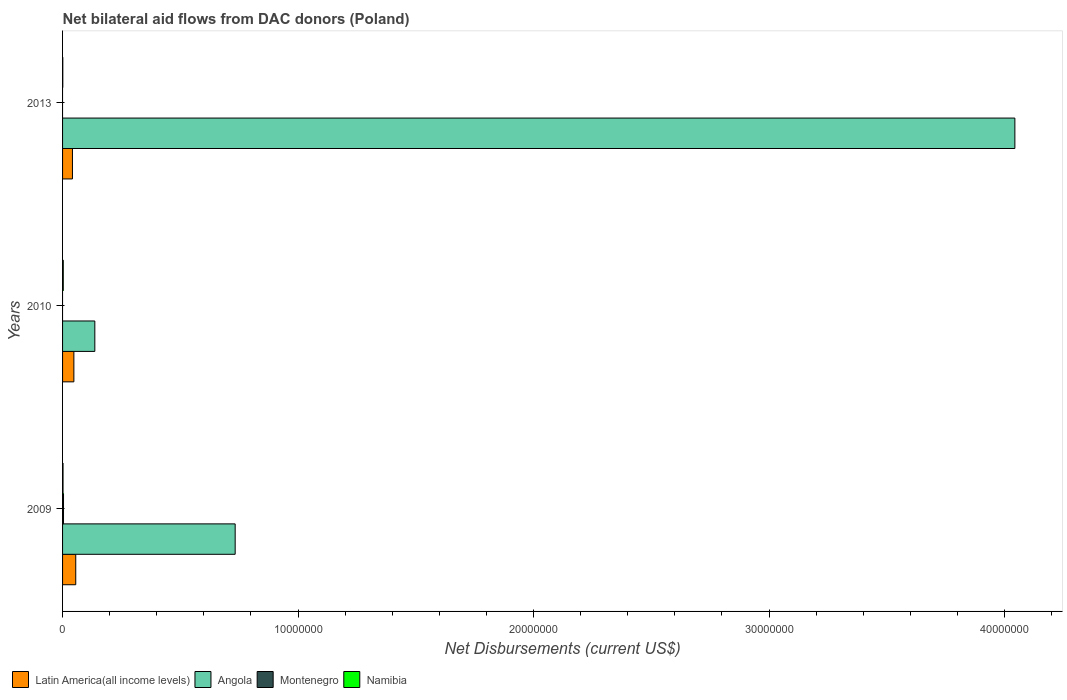How many different coloured bars are there?
Ensure brevity in your answer.  4. Are the number of bars per tick equal to the number of legend labels?
Your response must be concise. No. Are the number of bars on each tick of the Y-axis equal?
Offer a very short reply. No. How many bars are there on the 1st tick from the top?
Provide a succinct answer. 3. How many bars are there on the 2nd tick from the bottom?
Your answer should be very brief. 3. What is the label of the 3rd group of bars from the top?
Your answer should be compact. 2009. What is the net bilateral aid flows in Namibia in 2009?
Your response must be concise. 2.00e+04. Across all years, what is the maximum net bilateral aid flows in Latin America(all income levels)?
Keep it short and to the point. 5.60e+05. What is the total net bilateral aid flows in Namibia in the graph?
Offer a terse response. 6.00e+04. What is the difference between the net bilateral aid flows in Angola in 2009 and that in 2013?
Your answer should be compact. -3.31e+07. What is the average net bilateral aid flows in Latin America(all income levels) per year?
Your answer should be very brief. 4.87e+05. In the year 2010, what is the difference between the net bilateral aid flows in Angola and net bilateral aid flows in Latin America(all income levels)?
Offer a very short reply. 8.90e+05. What is the ratio of the net bilateral aid flows in Namibia in 2009 to that in 2010?
Offer a terse response. 0.67. Is the net bilateral aid flows in Namibia in 2009 less than that in 2010?
Provide a short and direct response. Yes. What is the difference between the highest and the lowest net bilateral aid flows in Namibia?
Your answer should be compact. 2.00e+04. In how many years, is the net bilateral aid flows in Namibia greater than the average net bilateral aid flows in Namibia taken over all years?
Keep it short and to the point. 1. Is it the case that in every year, the sum of the net bilateral aid flows in Angola and net bilateral aid flows in Namibia is greater than the net bilateral aid flows in Latin America(all income levels)?
Keep it short and to the point. Yes. How many bars are there?
Give a very brief answer. 10. How many years are there in the graph?
Offer a terse response. 3. Are the values on the major ticks of X-axis written in scientific E-notation?
Your response must be concise. No. How are the legend labels stacked?
Offer a very short reply. Horizontal. What is the title of the graph?
Make the answer very short. Net bilateral aid flows from DAC donors (Poland). Does "Algeria" appear as one of the legend labels in the graph?
Give a very brief answer. No. What is the label or title of the X-axis?
Offer a very short reply. Net Disbursements (current US$). What is the label or title of the Y-axis?
Offer a terse response. Years. What is the Net Disbursements (current US$) of Latin America(all income levels) in 2009?
Make the answer very short. 5.60e+05. What is the Net Disbursements (current US$) in Angola in 2009?
Offer a very short reply. 7.33e+06. What is the Net Disbursements (current US$) in Angola in 2010?
Offer a very short reply. 1.37e+06. What is the Net Disbursements (current US$) in Namibia in 2010?
Your response must be concise. 3.00e+04. What is the Net Disbursements (current US$) in Latin America(all income levels) in 2013?
Give a very brief answer. 4.20e+05. What is the Net Disbursements (current US$) in Angola in 2013?
Ensure brevity in your answer.  4.04e+07. What is the Net Disbursements (current US$) in Namibia in 2013?
Your answer should be very brief. 10000. Across all years, what is the maximum Net Disbursements (current US$) of Latin America(all income levels)?
Your answer should be compact. 5.60e+05. Across all years, what is the maximum Net Disbursements (current US$) of Angola?
Offer a terse response. 4.04e+07. Across all years, what is the maximum Net Disbursements (current US$) of Montenegro?
Make the answer very short. 4.00e+04. Across all years, what is the minimum Net Disbursements (current US$) in Latin America(all income levels)?
Provide a succinct answer. 4.20e+05. Across all years, what is the minimum Net Disbursements (current US$) in Angola?
Your response must be concise. 1.37e+06. Across all years, what is the minimum Net Disbursements (current US$) in Montenegro?
Your response must be concise. 0. Across all years, what is the minimum Net Disbursements (current US$) in Namibia?
Ensure brevity in your answer.  10000. What is the total Net Disbursements (current US$) in Latin America(all income levels) in the graph?
Keep it short and to the point. 1.46e+06. What is the total Net Disbursements (current US$) of Angola in the graph?
Keep it short and to the point. 4.91e+07. What is the total Net Disbursements (current US$) of Montenegro in the graph?
Keep it short and to the point. 4.00e+04. What is the total Net Disbursements (current US$) in Namibia in the graph?
Keep it short and to the point. 6.00e+04. What is the difference between the Net Disbursements (current US$) of Latin America(all income levels) in 2009 and that in 2010?
Your answer should be compact. 8.00e+04. What is the difference between the Net Disbursements (current US$) in Angola in 2009 and that in 2010?
Offer a very short reply. 5.96e+06. What is the difference between the Net Disbursements (current US$) of Latin America(all income levels) in 2009 and that in 2013?
Provide a succinct answer. 1.40e+05. What is the difference between the Net Disbursements (current US$) in Angola in 2009 and that in 2013?
Your response must be concise. -3.31e+07. What is the difference between the Net Disbursements (current US$) of Latin America(all income levels) in 2010 and that in 2013?
Keep it short and to the point. 6.00e+04. What is the difference between the Net Disbursements (current US$) of Angola in 2010 and that in 2013?
Give a very brief answer. -3.91e+07. What is the difference between the Net Disbursements (current US$) in Latin America(all income levels) in 2009 and the Net Disbursements (current US$) in Angola in 2010?
Your answer should be very brief. -8.10e+05. What is the difference between the Net Disbursements (current US$) in Latin America(all income levels) in 2009 and the Net Disbursements (current US$) in Namibia in 2010?
Make the answer very short. 5.30e+05. What is the difference between the Net Disbursements (current US$) in Angola in 2009 and the Net Disbursements (current US$) in Namibia in 2010?
Provide a succinct answer. 7.30e+06. What is the difference between the Net Disbursements (current US$) in Montenegro in 2009 and the Net Disbursements (current US$) in Namibia in 2010?
Make the answer very short. 10000. What is the difference between the Net Disbursements (current US$) of Latin America(all income levels) in 2009 and the Net Disbursements (current US$) of Angola in 2013?
Offer a very short reply. -3.99e+07. What is the difference between the Net Disbursements (current US$) of Angola in 2009 and the Net Disbursements (current US$) of Namibia in 2013?
Your response must be concise. 7.32e+06. What is the difference between the Net Disbursements (current US$) of Montenegro in 2009 and the Net Disbursements (current US$) of Namibia in 2013?
Offer a terse response. 3.00e+04. What is the difference between the Net Disbursements (current US$) in Latin America(all income levels) in 2010 and the Net Disbursements (current US$) in Angola in 2013?
Your answer should be very brief. -4.00e+07. What is the difference between the Net Disbursements (current US$) of Angola in 2010 and the Net Disbursements (current US$) of Namibia in 2013?
Your answer should be very brief. 1.36e+06. What is the average Net Disbursements (current US$) in Latin America(all income levels) per year?
Your answer should be very brief. 4.87e+05. What is the average Net Disbursements (current US$) in Angola per year?
Your response must be concise. 1.64e+07. What is the average Net Disbursements (current US$) in Montenegro per year?
Offer a terse response. 1.33e+04. What is the average Net Disbursements (current US$) of Namibia per year?
Provide a succinct answer. 2.00e+04. In the year 2009, what is the difference between the Net Disbursements (current US$) in Latin America(all income levels) and Net Disbursements (current US$) in Angola?
Keep it short and to the point. -6.77e+06. In the year 2009, what is the difference between the Net Disbursements (current US$) in Latin America(all income levels) and Net Disbursements (current US$) in Montenegro?
Your answer should be very brief. 5.20e+05. In the year 2009, what is the difference between the Net Disbursements (current US$) of Latin America(all income levels) and Net Disbursements (current US$) of Namibia?
Make the answer very short. 5.40e+05. In the year 2009, what is the difference between the Net Disbursements (current US$) in Angola and Net Disbursements (current US$) in Montenegro?
Provide a short and direct response. 7.29e+06. In the year 2009, what is the difference between the Net Disbursements (current US$) of Angola and Net Disbursements (current US$) of Namibia?
Provide a short and direct response. 7.31e+06. In the year 2010, what is the difference between the Net Disbursements (current US$) of Latin America(all income levels) and Net Disbursements (current US$) of Angola?
Keep it short and to the point. -8.90e+05. In the year 2010, what is the difference between the Net Disbursements (current US$) in Angola and Net Disbursements (current US$) in Namibia?
Make the answer very short. 1.34e+06. In the year 2013, what is the difference between the Net Disbursements (current US$) in Latin America(all income levels) and Net Disbursements (current US$) in Angola?
Keep it short and to the point. -4.00e+07. In the year 2013, what is the difference between the Net Disbursements (current US$) of Angola and Net Disbursements (current US$) of Namibia?
Provide a short and direct response. 4.04e+07. What is the ratio of the Net Disbursements (current US$) of Angola in 2009 to that in 2010?
Your answer should be compact. 5.35. What is the ratio of the Net Disbursements (current US$) in Latin America(all income levels) in 2009 to that in 2013?
Provide a short and direct response. 1.33. What is the ratio of the Net Disbursements (current US$) of Angola in 2009 to that in 2013?
Offer a very short reply. 0.18. What is the ratio of the Net Disbursements (current US$) in Latin America(all income levels) in 2010 to that in 2013?
Keep it short and to the point. 1.14. What is the ratio of the Net Disbursements (current US$) in Angola in 2010 to that in 2013?
Keep it short and to the point. 0.03. What is the ratio of the Net Disbursements (current US$) of Namibia in 2010 to that in 2013?
Give a very brief answer. 3. What is the difference between the highest and the second highest Net Disbursements (current US$) in Latin America(all income levels)?
Ensure brevity in your answer.  8.00e+04. What is the difference between the highest and the second highest Net Disbursements (current US$) of Angola?
Keep it short and to the point. 3.31e+07. What is the difference between the highest and the second highest Net Disbursements (current US$) in Namibia?
Offer a very short reply. 10000. What is the difference between the highest and the lowest Net Disbursements (current US$) in Latin America(all income levels)?
Ensure brevity in your answer.  1.40e+05. What is the difference between the highest and the lowest Net Disbursements (current US$) of Angola?
Give a very brief answer. 3.91e+07. What is the difference between the highest and the lowest Net Disbursements (current US$) in Namibia?
Keep it short and to the point. 2.00e+04. 